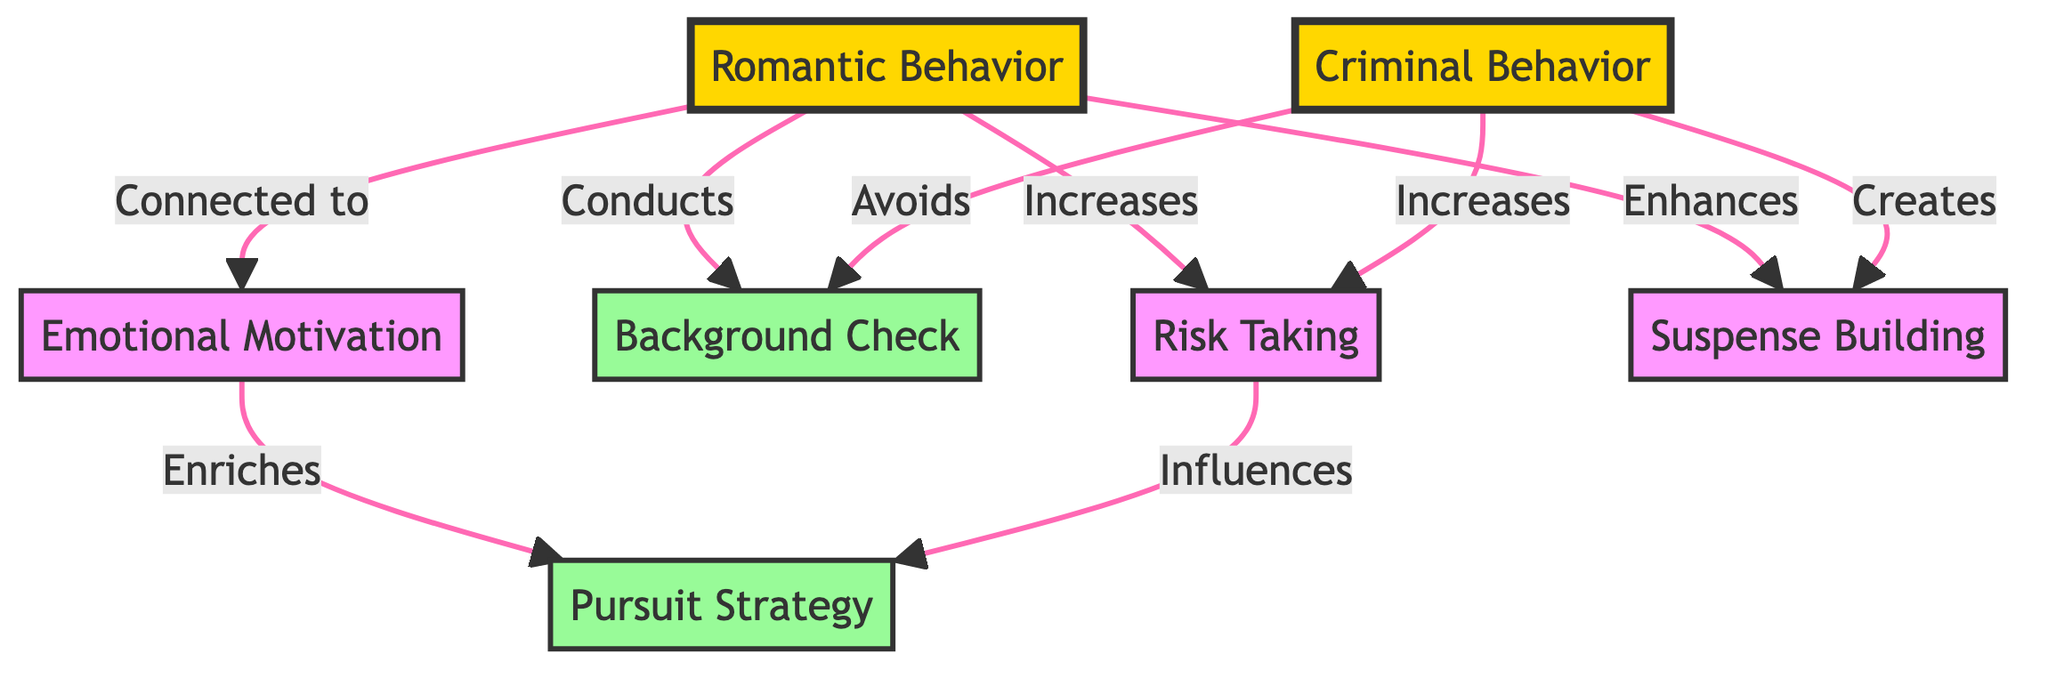What are the two primary types of behavior illustrated in the diagram? The diagram illustrates two primary types of behavior: Criminal Behavior and Romantic Behavior. Each behavior is shown with its distinct node in the flowchart.
Answer: Criminal Behavior and Romantic Behavior How many action nodes are present in the diagram? There are three action nodes in the diagram: Background Check, Pursuit Strategy, and Suspense Building. Counting each of these, we confirm the total is three.
Answer: 3 Which behavior is associated with conducting a background check? The diagram indicates that Romantic Behavior is associated with conducting a background check, as represented by the directed edge from RB to BC.
Answer: Romantic Behavior What effect does risk-taking have on pursuit strategy? The diagram shows that risk-taking influences pursuit strategy, as indicated by the arrow pointing from Risk Taking to Pursuit Strategy, meaning there's a direct relationship.
Answer: Influences How does emotional motivation relate to pursuit strategy? The diagram states that emotional motivation enriches pursuit strategy, demonstrating that emotional motivation plays a supportive role in shaping how one pursues romantically.
Answer: Enriches Which type of behavior avoids background checks? The diagram shows that Criminal Behavior avoids background checks, represented by the edge connecting Criminal Behavior to Background Check, indicating a lack of engagement with this action.
Answer: Criminal Behavior What is the relationship between suspense building and both types of behavior? The diagram indicates that both Criminal Behavior and Romantic Behavior are associated with suspense building, with Criminal Behavior creating suspense and Romantic Behavior enhancing it.
Answer: Creates and Enhances How many connections are there involving the risk-taking node? The risk-taking node has two connections: one from Criminal Behavior and one from Romantic Behavior, making for a total of two directed edges stemming from the Risk Taking node.
Answer: 2 What is the connection between romantic behavior and emotional motivation? The diagram shows that Romantic Behavior is connected to emotional motivation, as indicated by the link from Romantic Behavior to Emotional Motivation, illustrating a positive relationship.
Answer: Connected to 